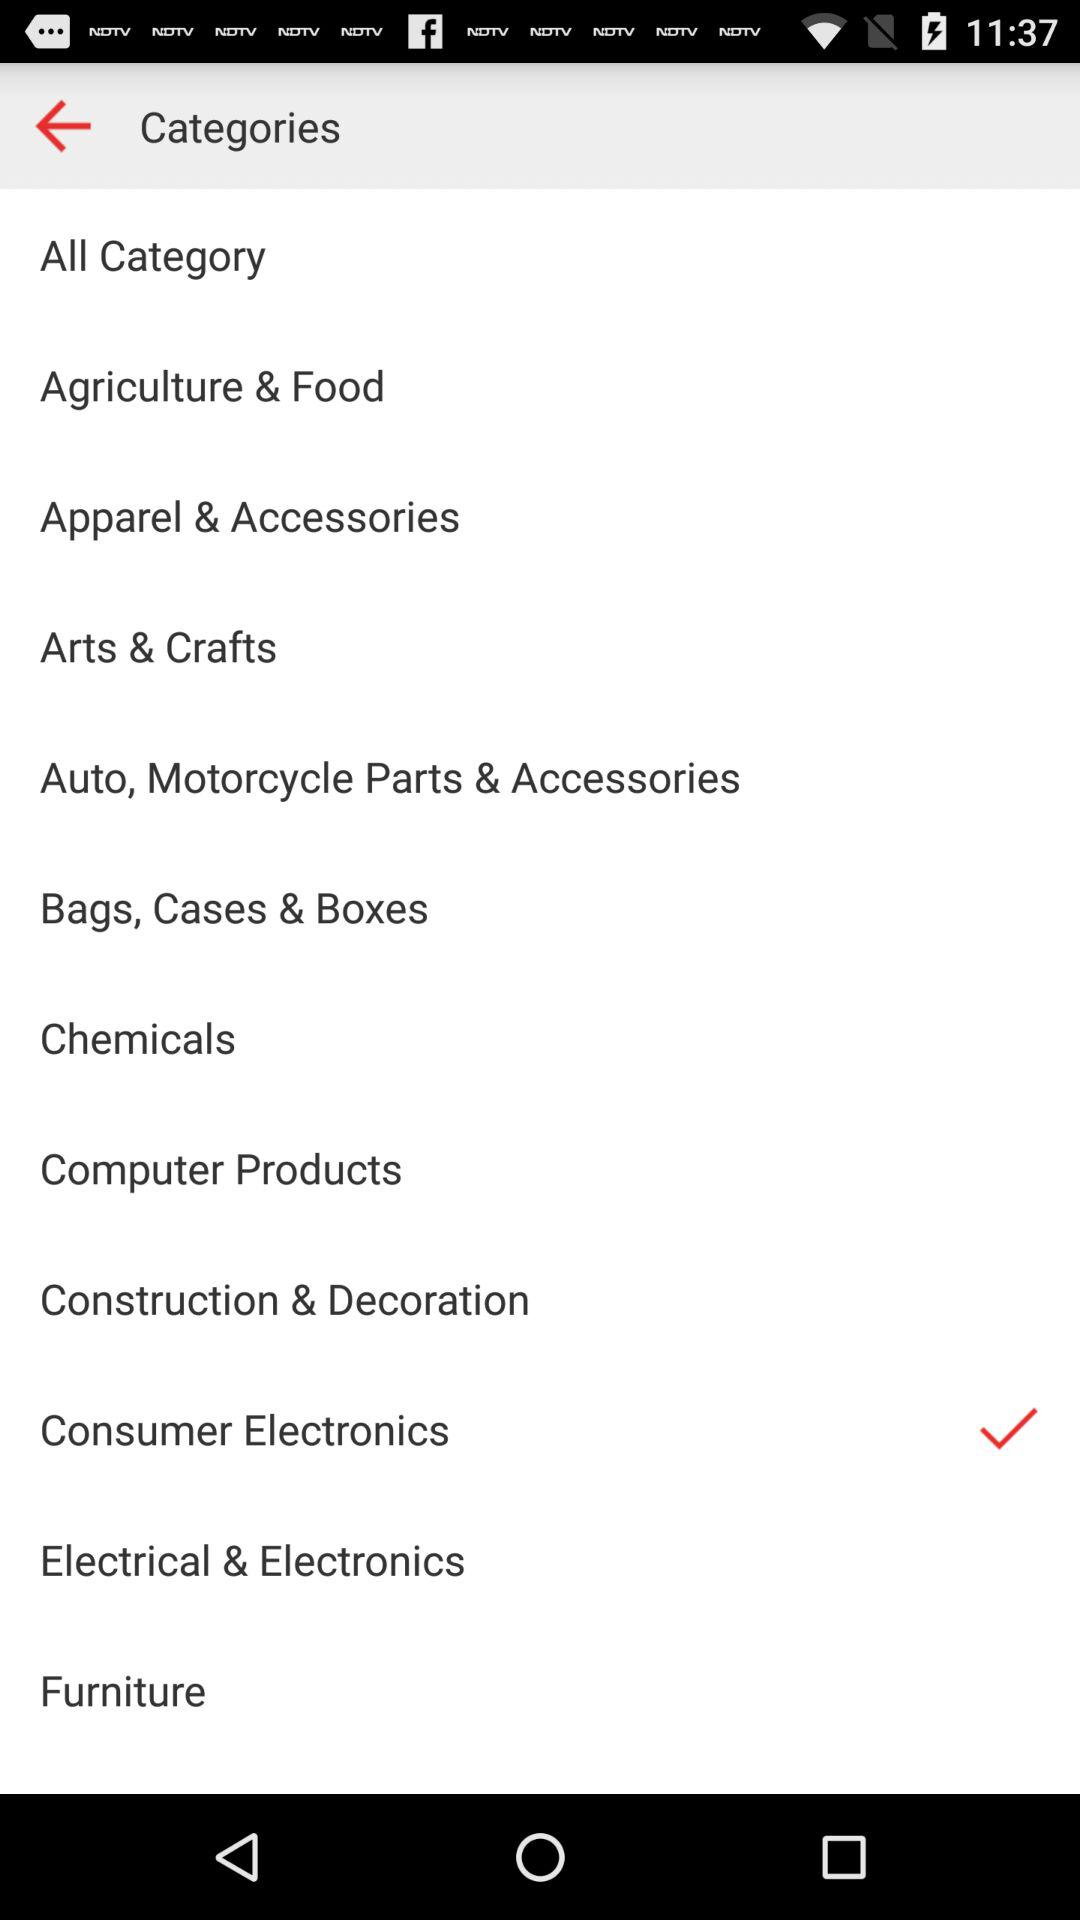What is the selected option? The selected option is "Consumer Electronics". 